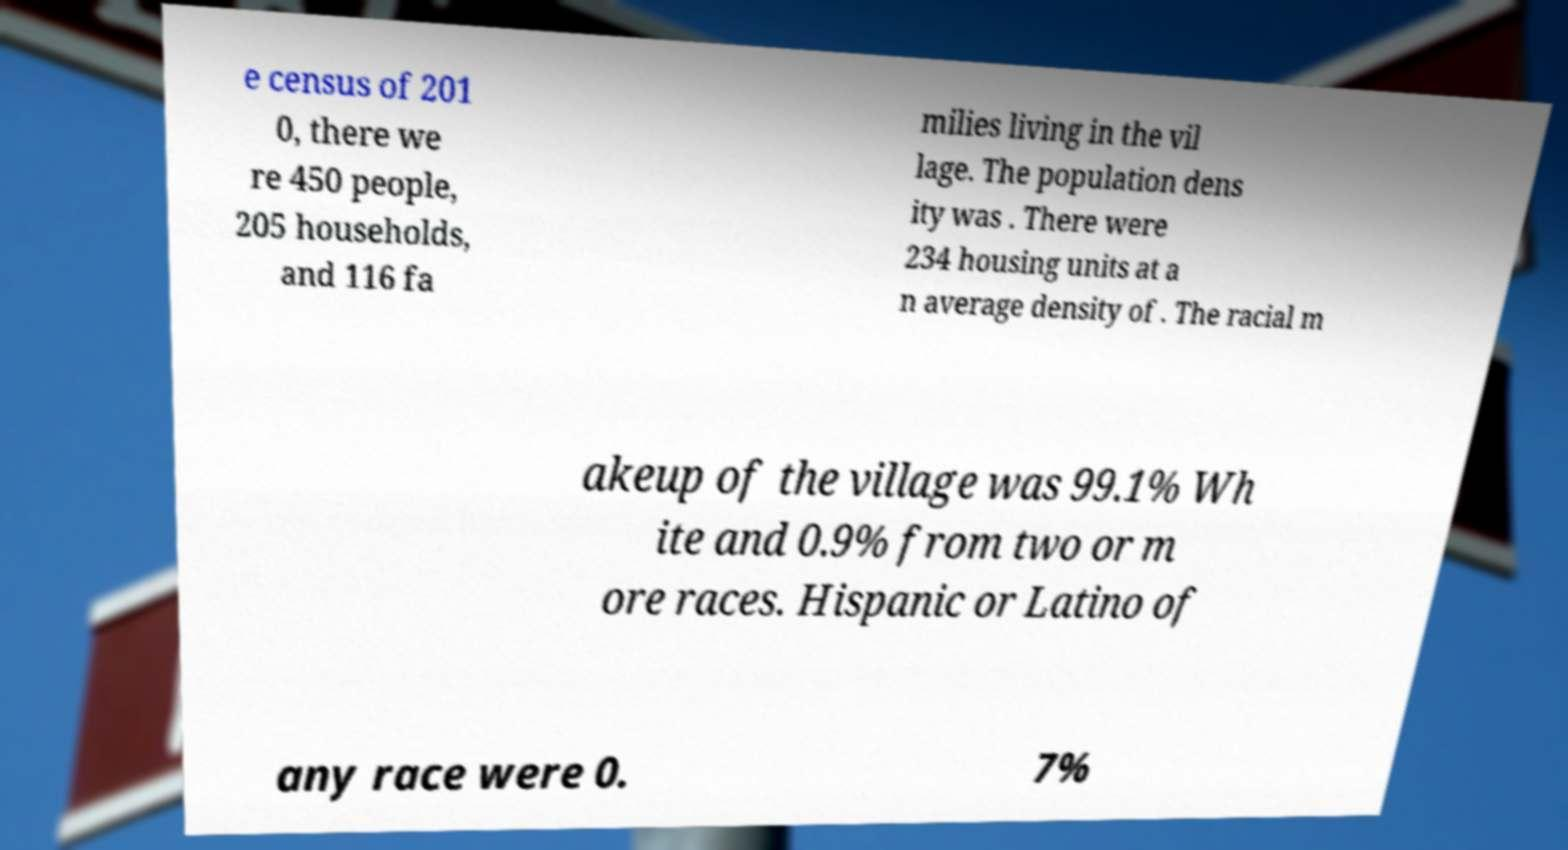For documentation purposes, I need the text within this image transcribed. Could you provide that? e census of 201 0, there we re 450 people, 205 households, and 116 fa milies living in the vil lage. The population dens ity was . There were 234 housing units at a n average density of . The racial m akeup of the village was 99.1% Wh ite and 0.9% from two or m ore races. Hispanic or Latino of any race were 0. 7% 